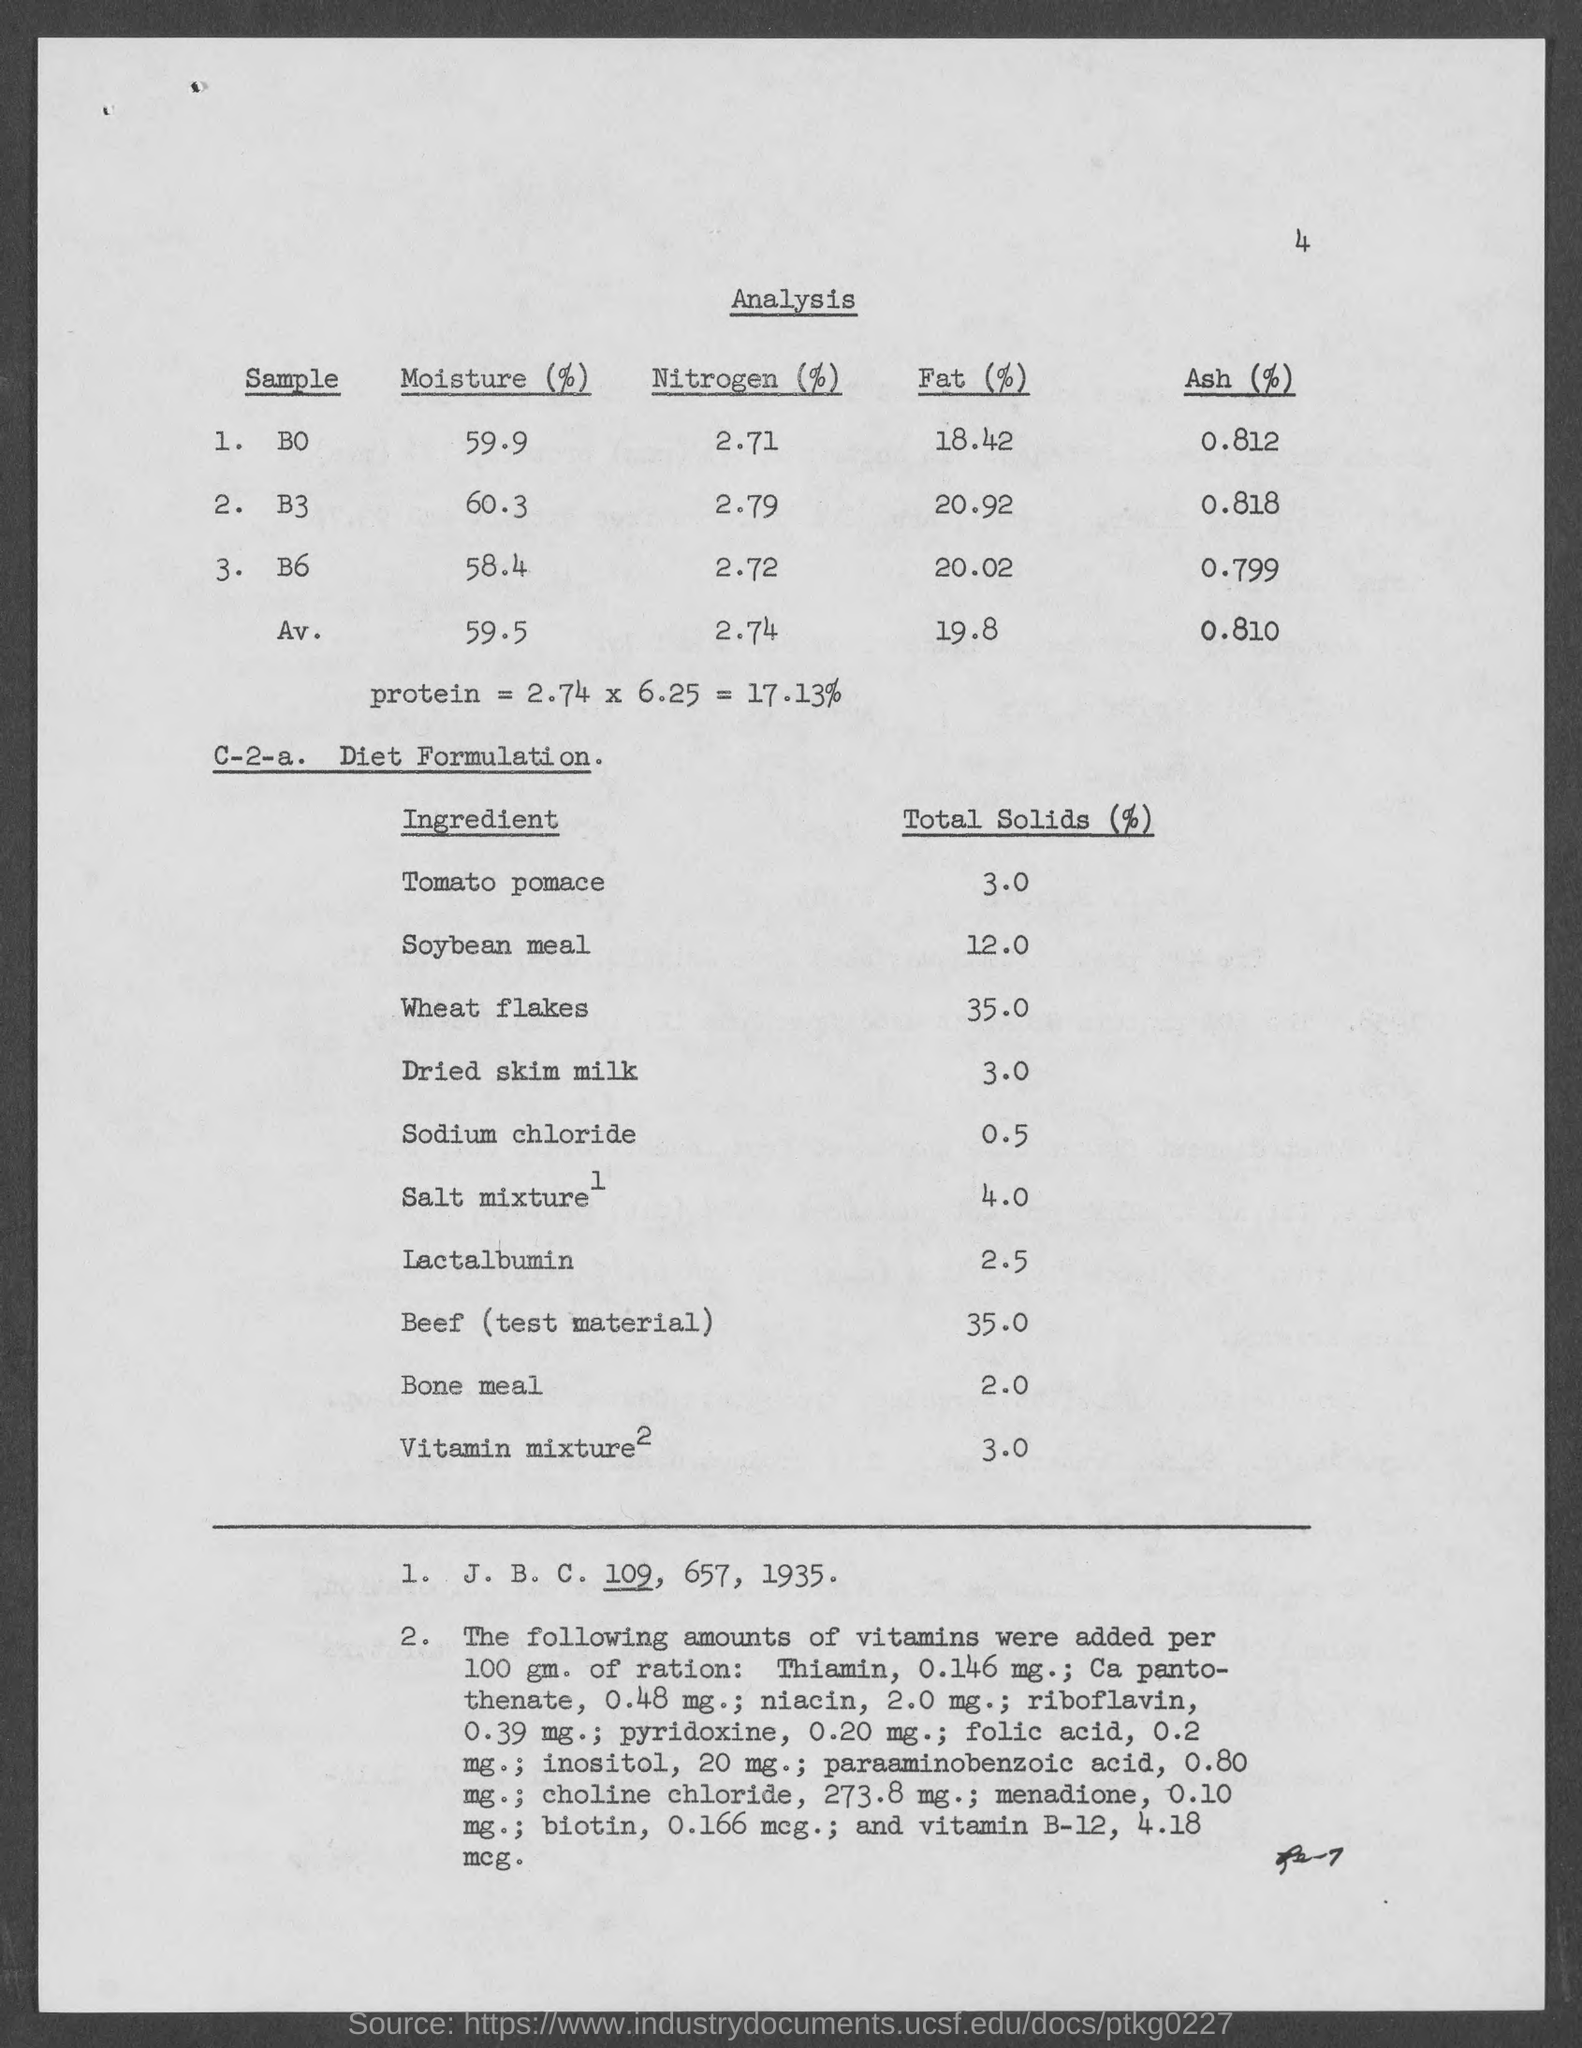Specify some key components in this picture. The analysis of sample B3 revealed that 2.79% of its composition is nitrogen. The sample B0 contains 59.9% moisture, based on the analysis. The total solids in the soyabean meal used in the diet formulation are 12%. The total solids content in wheat flakes is 35% as per the diet formulation. The analysis of the sample B0 showed that 8.12% of its composition was Ash. 